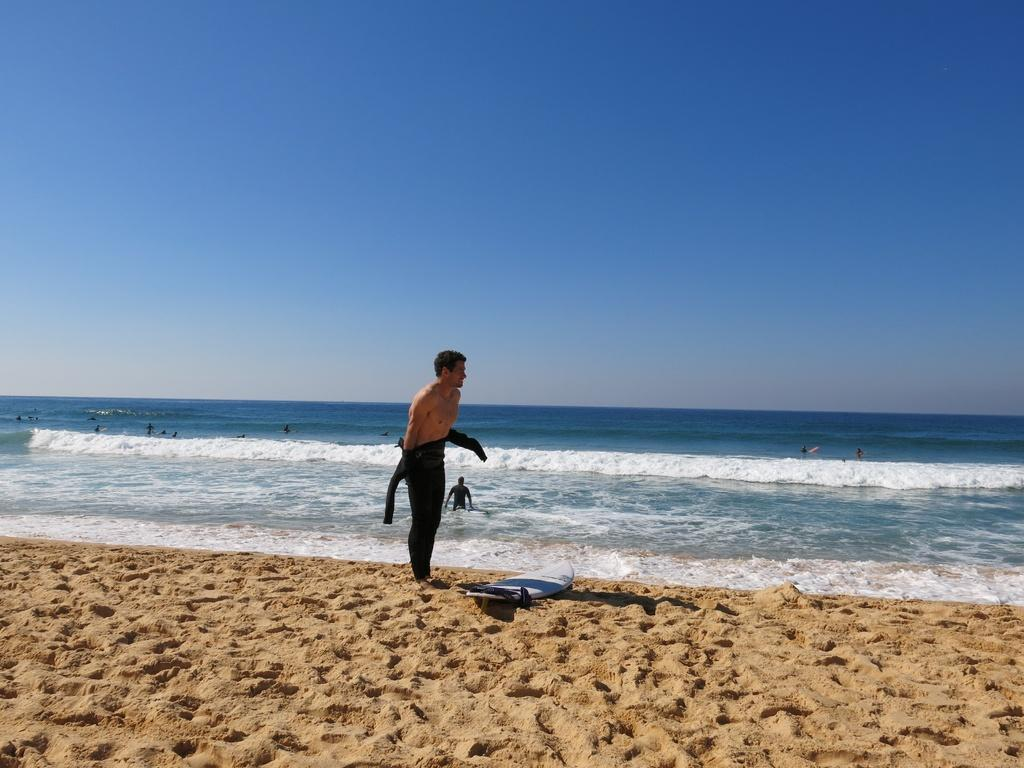What is the person standing on the land holding in the image? The person is holding a surfboard. What are the people in the water doing in the image? The people in the water are experiencing tides. What can be seen at the top of the image? The sky is visible at the top of the image. What type of flowers can be seen growing on the surfboard in the image? There are no flowers present on the surfboard in the image. Is there a bottle of paint visible in the water in the image? There is no bottle of paint visible in the water in the image. 